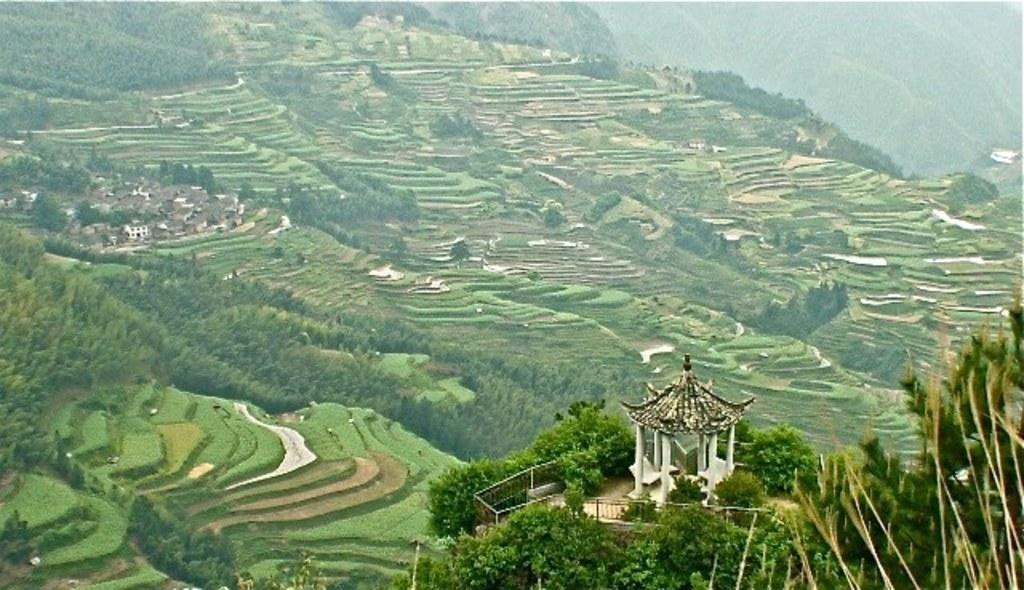What type of landscape is depicted in the image? The image features fields, trees, and mountains. Are there any man-made structures visible in the image? Yes, there are buildings in the image. What type of vegetation can be seen in the image? The image includes trees and plants. What is the purpose of the fence in the image? The fence in the image serves as a boundary or divider. How many servants are attending to the home in the image? There is no home or servants present in the image. What type of bath can be seen in the image? There is no bath visible in the image. 